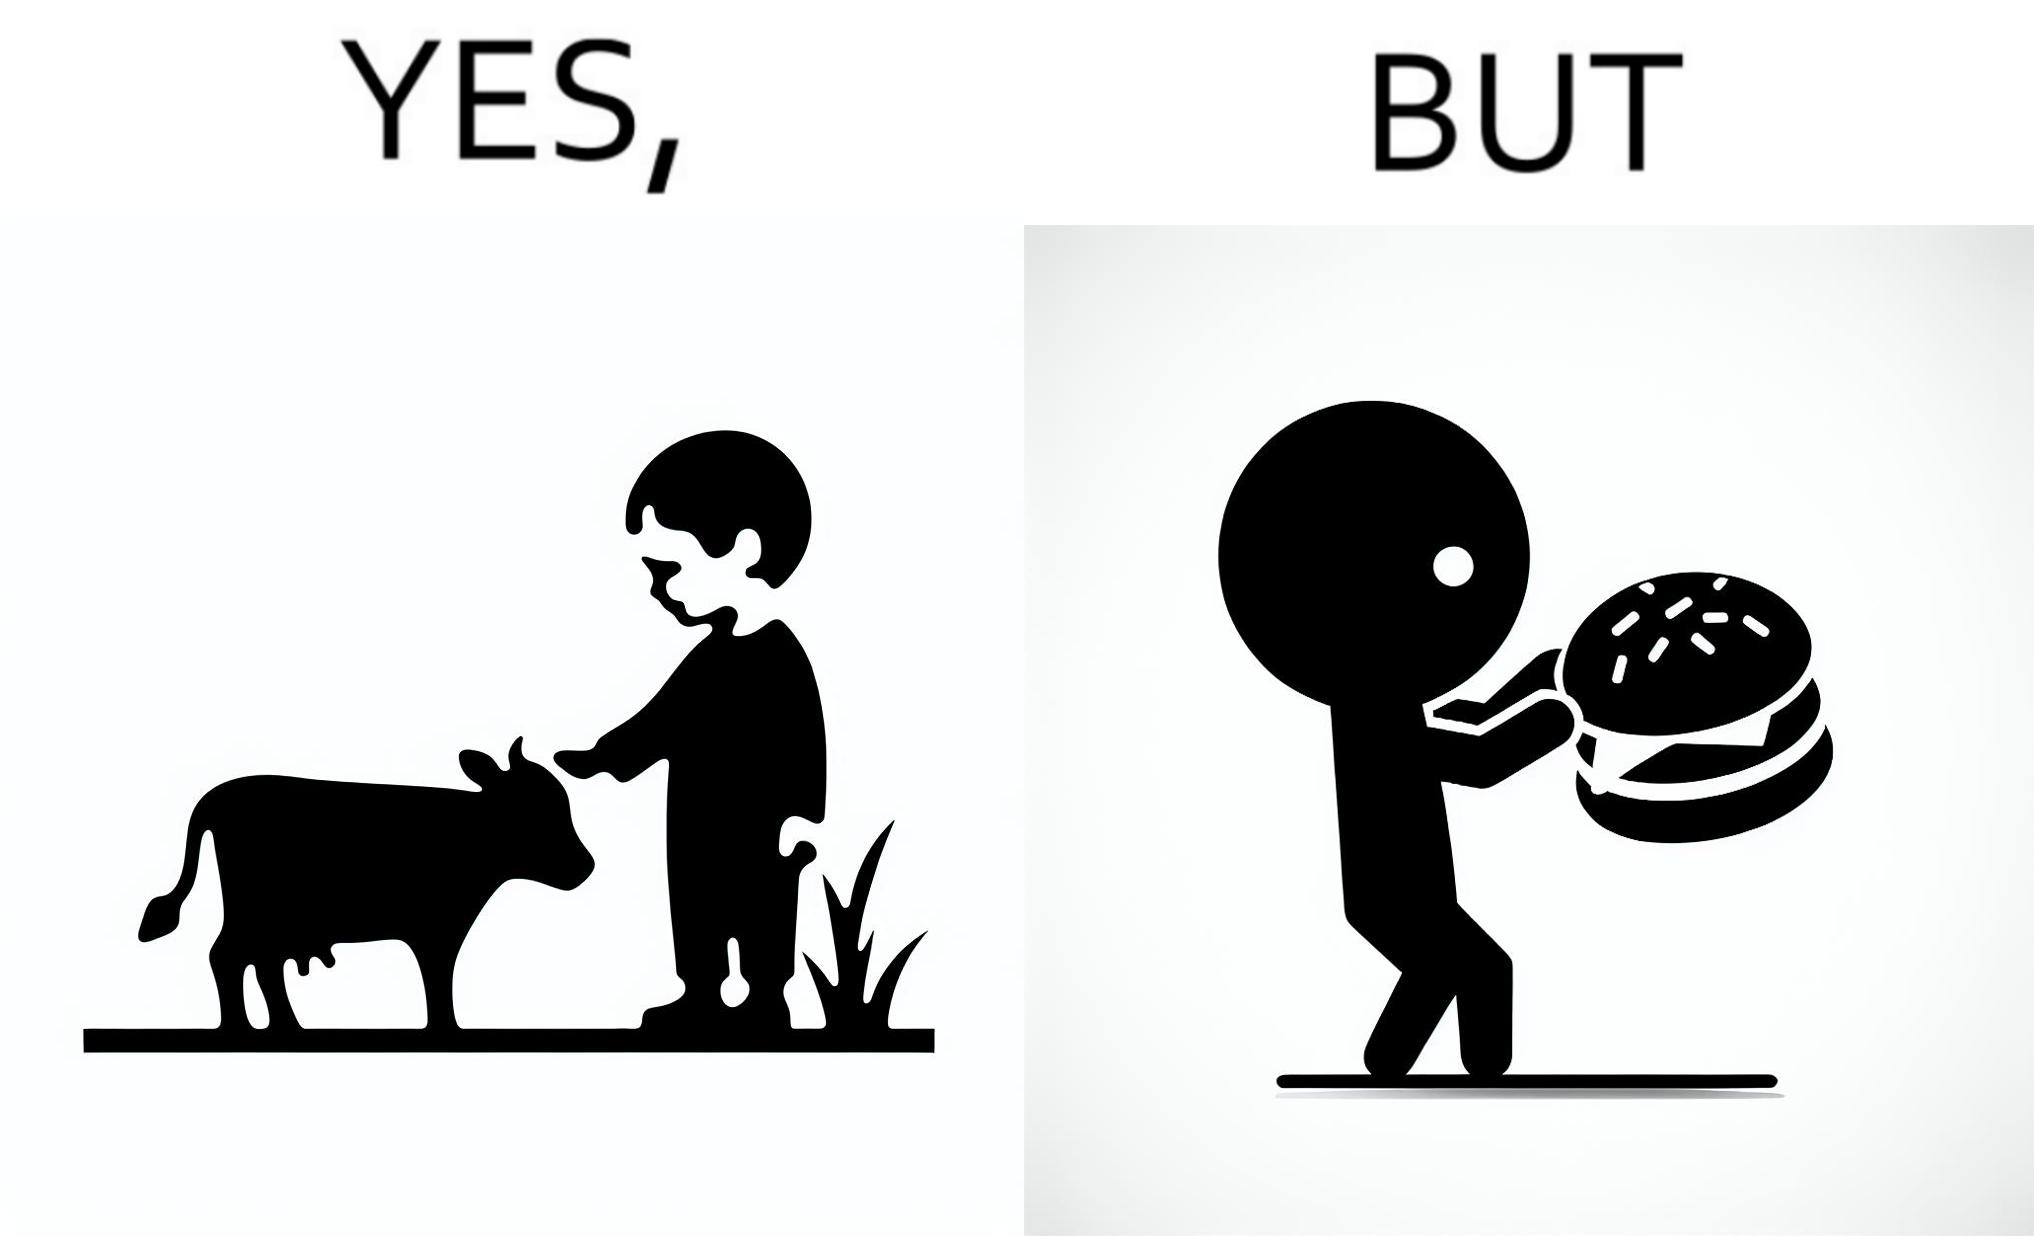What is the satirical meaning behind this image? The irony is that the boy is petting the cow to show that he cares about the animal, but then he also eats hamburgers made from the same cows 